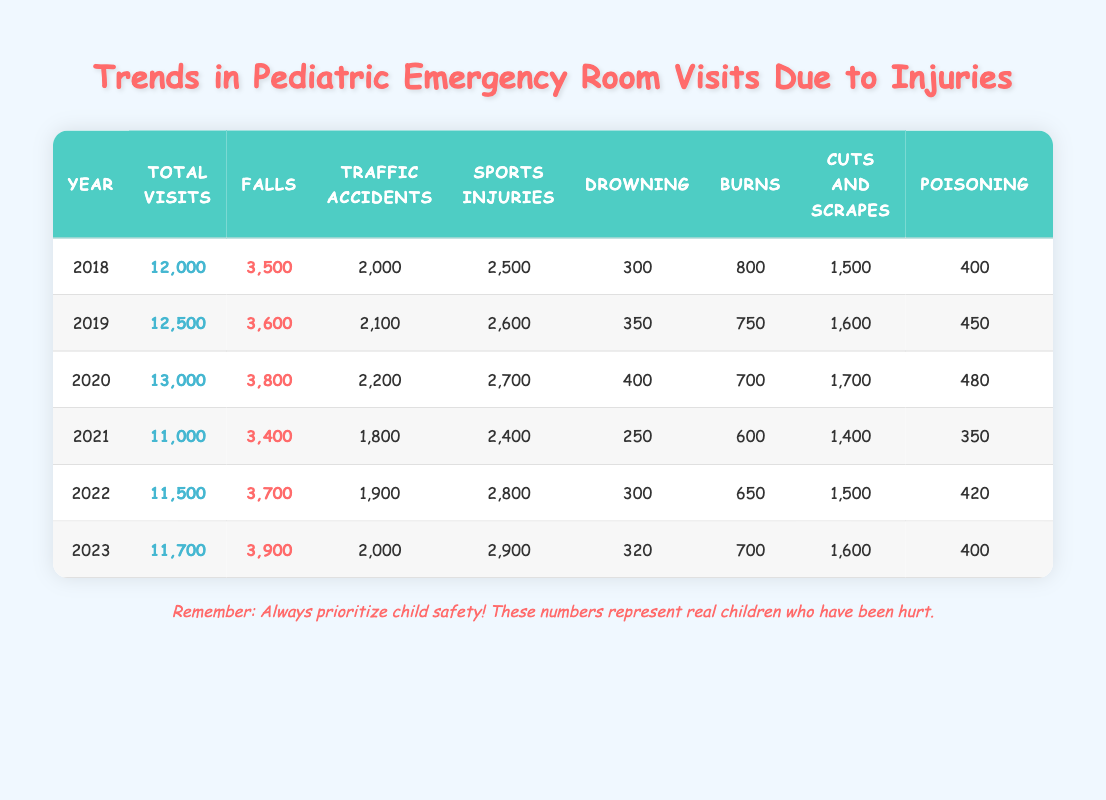What was the total number of pediatric emergency room visits in 2020? In the row for 2020, the "Total Visits" column shows the total number of visits for that year. It states 13,000.
Answer: 13,000 Which injury type had the highest number of visits in 2022? In the 2022 row, comparing all injury types, "Sports Injuries" has the highest count at 2,800.
Answer: Sports Injuries What is the difference in total visits between 2018 and 2023? For 2018, the total visits are 12,000, and for 2023, they are 11,700. The difference is 12,000 - 11,700 = 300.
Answer: 300 Did the number of drowning incidents increase from 2018 to 2023? In the year 2018, there were 300 drowning incidents, while in 2023, there were 320. This indicates an increase.
Answer: Yes What was the average number of traffic accident visits over the years presented? To find the average, sum the traffic accident visits from each year: (2000 + 2100 + 2200 + 1800 + 1900 + 2000) = 12,000. Then, divide by 6 (the number of years) giving 12,000 / 6 = 2000.
Answer: 2000 Which year had the least number of cuts and scrapes? By examining the "Cuts and Scrapes" column, 2021 has the least incidents at 1,400.
Answer: 2021 How many more falls were reported in 2023 compared to 2021? In 2023, there were 3,900 falls, while in 2021 there were 3,400. The difference is 3,900 - 3,400 = 500 more falls in 2023.
Answer: 500 What percentage of total visits in 2019 were due to sports injuries? In 2019, there were 12,500 total visits and 2,600 sports injuries. The percentage is (2,600 / 12,500) * 100 ≈ 20.8%.
Answer: Approximately 20.8% Is it true that the number of burns decreased from 2018 to 2021? In 2018, there were 800 burns, but by 2021 this number decreased to 600. Therefore, this statement is true.
Answer: Yes 